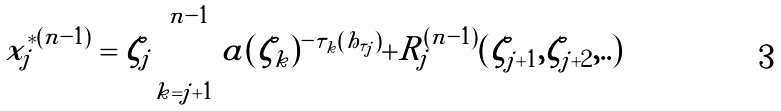<formula> <loc_0><loc_0><loc_500><loc_500>x _ { j } ^ { * ( n - 1 ) } = \zeta _ { j } \prod _ { k = j + 1 } ^ { n - 1 } a ( \zeta _ { k } ) ^ { - \tau _ { k } ( h _ { \tau _ { j } } ) } + R _ { j } ^ { ( n - 1 ) } ( \zeta _ { j + 1 } , \zeta _ { j + 2 } , . . )</formula> 